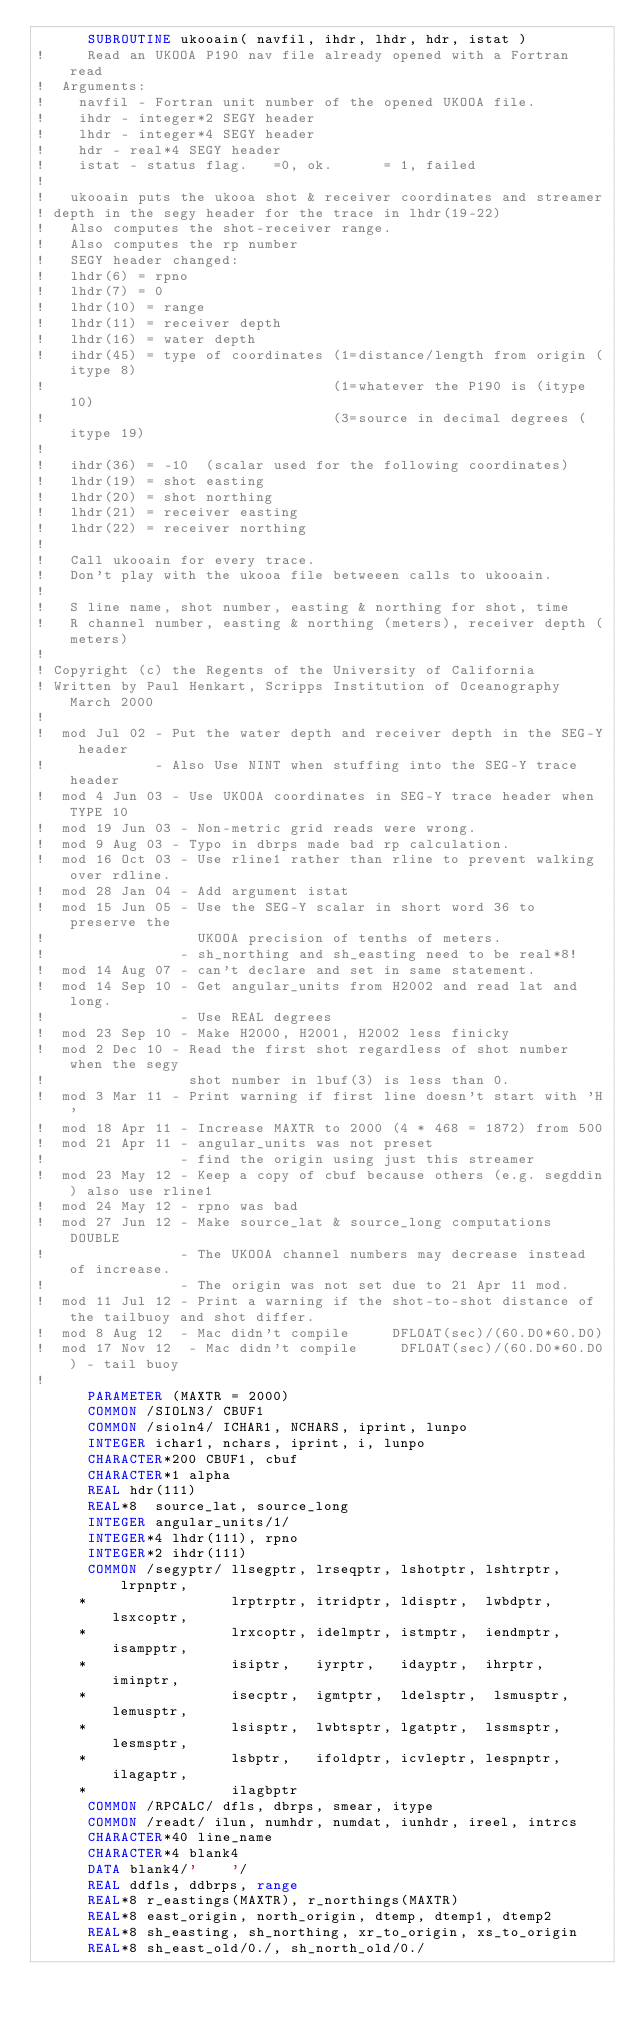<code> <loc_0><loc_0><loc_500><loc_500><_FORTRAN_>      SUBROUTINE ukooain( navfil, ihdr, lhdr, hdr, istat )
!     Read an UKOOA P190 nav file already opened with a Fortran read
!  Arguments:
!    navfil - Fortran unit number of the opened UKOOA file.
!    ihdr - integer*2 SEGY header
!    lhdr - integer*4 SEGY header
!    hdr - real*4 SEGY header
!    istat - status flag.   =0, ok.      = 1, failed
!
!   ukooain puts the ukooa shot & receiver coordinates and streamer
! depth in the segy header for the trace in lhdr(19-22)
!   Also computes the shot-receiver range.
!   Also computes the rp number
!   SEGY header changed:
!   lhdr(6) = rpno
!   lhdr(7) = 0
!   lhdr(10) = range
!   lhdr(11) = receiver depth
!   lhdr(16) = water depth
!   ihdr(45) = type of coordinates (1=distance/length from origin (itype 8)
!                                  (1=whatever the P190 is (itype 10)
!                                  (3=source in decimal degrees (itype 19)
!                                  
!   ihdr(36) = -10  (scalar used for the following coordinates)
!   lhdr(19) = shot easting
!   lhdr(20) = shot northing
!   lhdr(21) = receiver easting
!   lhdr(22) = receiver northing
!
!   Call ukooain for every trace.
!   Don't play with the ukooa file betweeen calls to ukooain.
!
!   S line name, shot number, easting & northing for shot, time
!   R channel number, easting & northing (meters), receiver depth (meters)
!
! Copyright (c) the Regents of the University of California
! Written by Paul Henkart, Scripps Institution of Oceanography March 2000
!
!  mod Jul 02 - Put the water depth and receiver depth in the SEG-Y header
!             - Also Use NINT when stuffing into the SEG-Y trace header
!  mod 4 Jun 03 - Use UKOOA coordinates in SEG-Y trace header when TYPE 10
!  mod 19 Jun 03 - Non-metric grid reads were wrong.
!  mod 9 Aug 03 - Typo in dbrps made bad rp calculation.
!  mod 16 Oct 03 - Use rline1 rather than rline to prevent walking over rdline.
!  mod 28 Jan 04 - Add argument istat
!  mod 15 Jun 05 - Use the SEG-Y scalar in short word 36 to preserve the
!                  UKOOA precision of tenths of meters.
!                - sh_northing and sh_easting need to be real*8!
!  mod 14 Aug 07 - can't declare and set in same statement.
!  mod 14 Sep 10 - Get angular_units from H2002 and read lat and long.
!                - Use REAL degrees
!  mod 23 Sep 10 - Make H2000, H2001, H2002 less finicky
!  mod 2 Dec 10 - Read the first shot regardless of shot number when the segy
!                 shot number in lbuf(3) is less than 0.
!  mod 3 Mar 11 - Print warning if first line doesn't start with 'H'
!  mod 18 Apr 11 - Increase MAXTR to 2000 (4 * 468 = 1872) from 500
!  mod 21 Apr 11 - angular_units was not preset
!                - find the origin using just this streamer
!  mod 23 May 12 - Keep a copy of cbuf because others (e.g. segddin) also use rline1
!  mod 24 May 12 - rpno was bad
!  mod 27 Jun 12 - Make source_lat & source_long computations DOUBLE
!                - The UKOOA channel numbers may decrease instead of increase.
!                - The origin was not set due to 21 Apr 11 mod.
!  mod 11 Jul 12 - Print a warning if the shot-to-shot distance of the tailbuoy and shot differ.
!  mod 8 Aug 12  - Mac didn't compile     DFLOAT(sec)/(60.D0*60.D0)
!  mod 17 Nov 12  - Mac didn't compile     DFLOAT(sec)/(60.D0*60.D0) - tail buoy
!
      PARAMETER (MAXTR = 2000)
      COMMON /SIOLN3/ CBUF1
      COMMON /sioln4/ ICHAR1, NCHARS, iprint, lunpo
      INTEGER ichar1, nchars, iprint, i, lunpo
      CHARACTER*200 CBUF1, cbuf
      CHARACTER*1 alpha
      REAL hdr(111)
      REAL*8  source_lat, source_long
      INTEGER angular_units/1/
      INTEGER*4 lhdr(111), rpno
      INTEGER*2 ihdr(111)
      COMMON /segyptr/ llsegptr, lrseqptr, lshotptr, lshtrptr, lrpnptr,
     *                 lrptrptr, itridptr, ldisptr,  lwbdptr,  lsxcoptr,
     *                 lrxcoptr, idelmptr, istmptr,  iendmptr, isampptr,
     *                 isiptr,   iyrptr,   idayptr,  ihrptr,   iminptr,
     *                 isecptr,  igmtptr,  ldelsptr,  lsmusptr,lemusptr,
     *                 lsisptr,  lwbtsptr, lgatptr,  lssmsptr, lesmsptr,
     *                 lsbptr,   ifoldptr, icvleptr, lespnptr, ilagaptr,
     *                 ilagbptr
      COMMON /RPCALC/ dfls, dbrps, smear, itype
      COMMON /readt/ ilun, numhdr, numdat, iunhdr, ireel, intrcs
      CHARACTER*40 line_name
      CHARACTER*4 blank4
      DATA blank4/'    '/
      REAL ddfls, ddbrps, range
      REAL*8 r_eastings(MAXTR), r_northings(MAXTR)
      REAL*8 east_origin, north_origin, dtemp, dtemp1, dtemp2
      REAL*8 sh_easting, sh_northing, xr_to_origin, xs_to_origin
      REAL*8 sh_east_old/0./, sh_north_old/0./</code> 